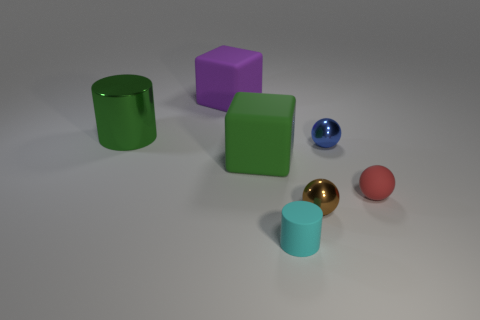Add 3 tiny gray rubber things. How many objects exist? 10 Subtract 0 purple balls. How many objects are left? 7 Subtract all blocks. How many objects are left? 5 Subtract all large green matte cylinders. Subtract all tiny blue shiny things. How many objects are left? 6 Add 6 tiny brown shiny things. How many tiny brown shiny things are left? 7 Add 1 tiny gray metallic cylinders. How many tiny gray metallic cylinders exist? 1 